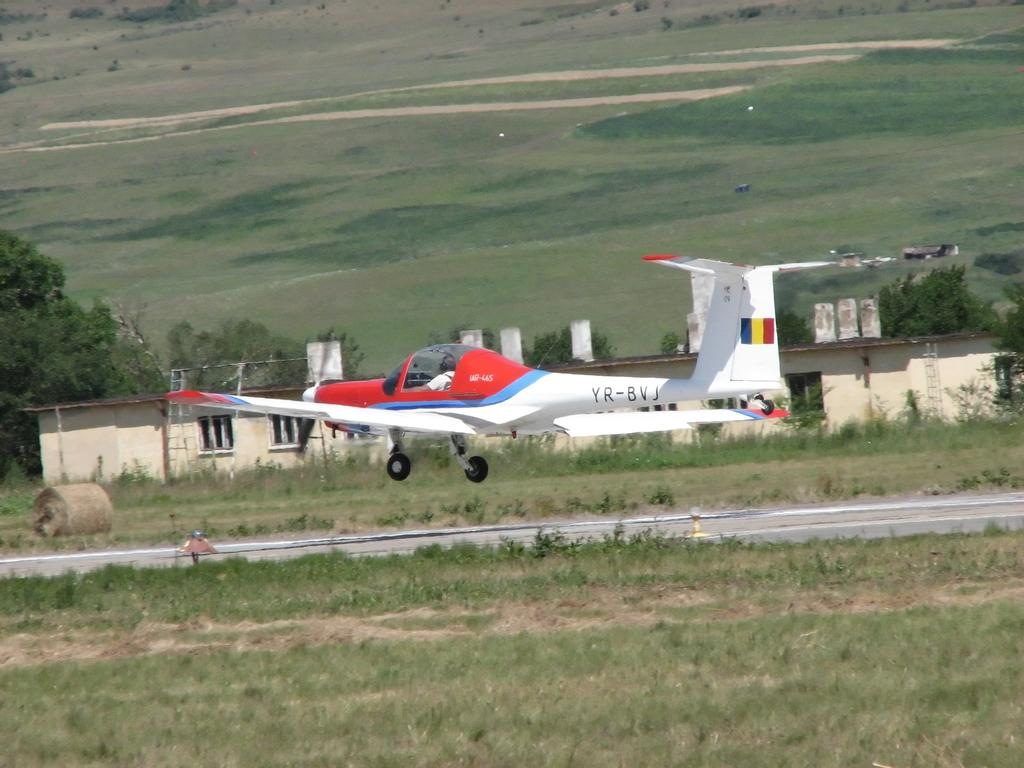What is the person in the image doing? The person is sitting in an airplane. What can be seen outside the airplane? There is a runway visible in the image. What type of vegetation is present in the image? Grass and plants are visible in the image. What object is on the ground near the airplane? There is a roller on the ground. Can you describe the house in the image? The house has windows. What else can be seen in the natural environment in the image? A group of trees is present in the image. How many chickens are visible in the image? There are no chickens present in the image. What type of basket is being used to carry the milk in the image? There is no basket or milk present in the image. 